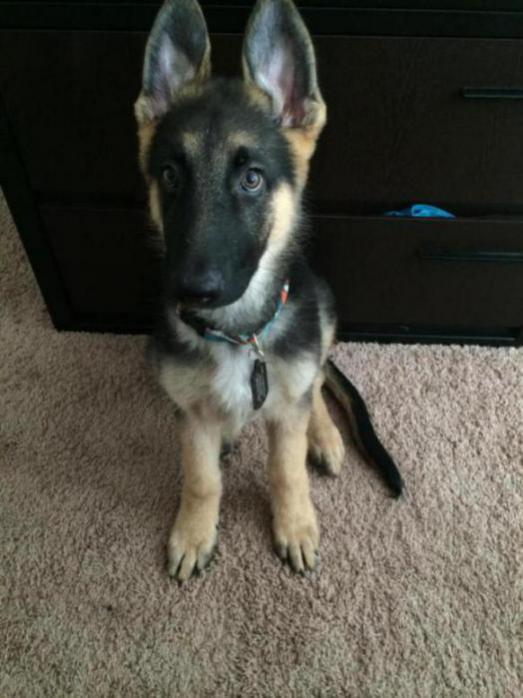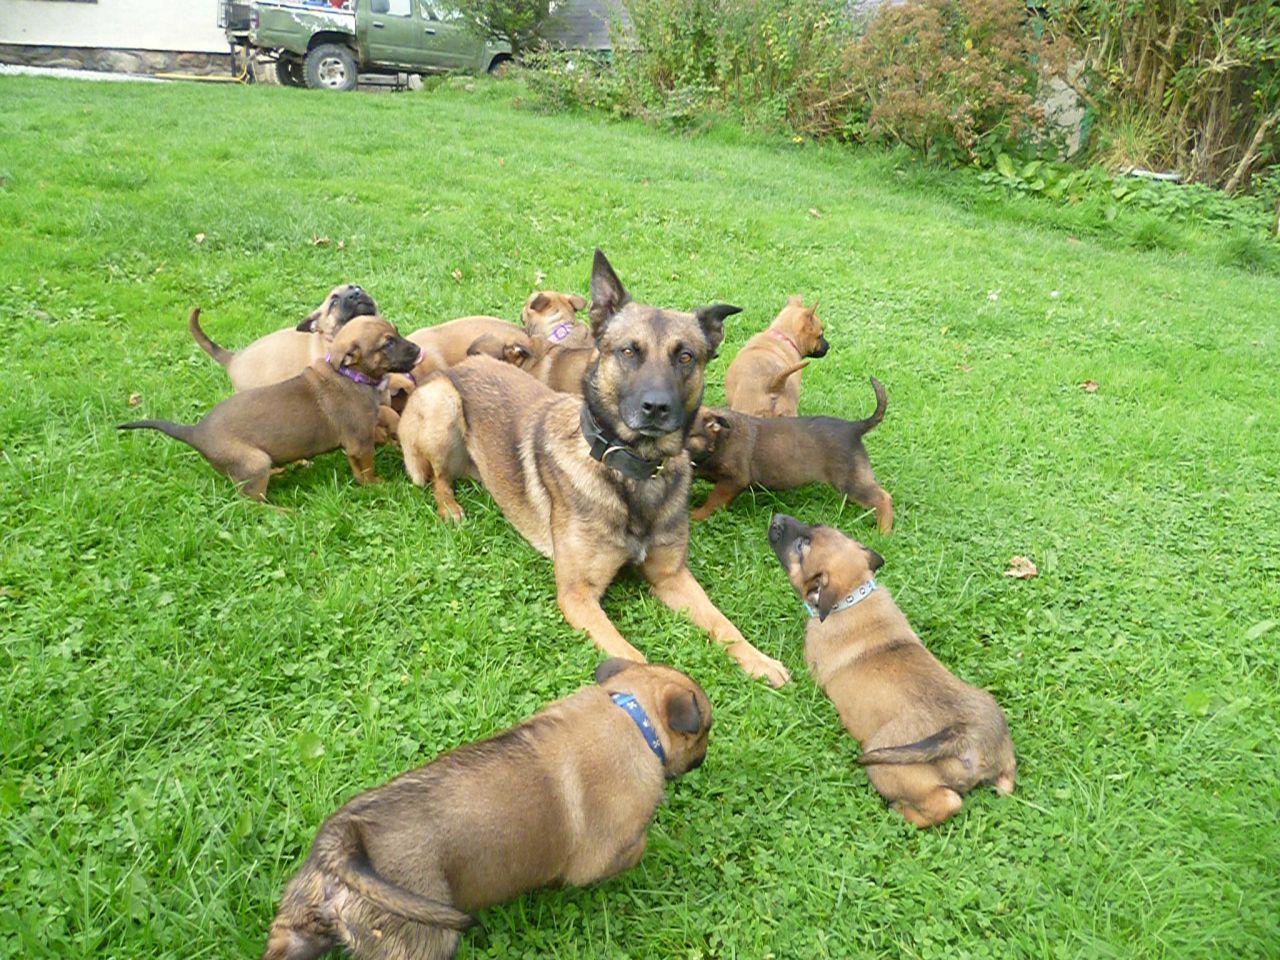The first image is the image on the left, the second image is the image on the right. Assess this claim about the two images: "An image shows only one dog, which is standing on a hard surface and wearing a leash.". Correct or not? Answer yes or no. No. The first image is the image on the left, the second image is the image on the right. Given the left and right images, does the statement "There are two dogs in total and one of them is standing on grass.›" hold true? Answer yes or no. No. 